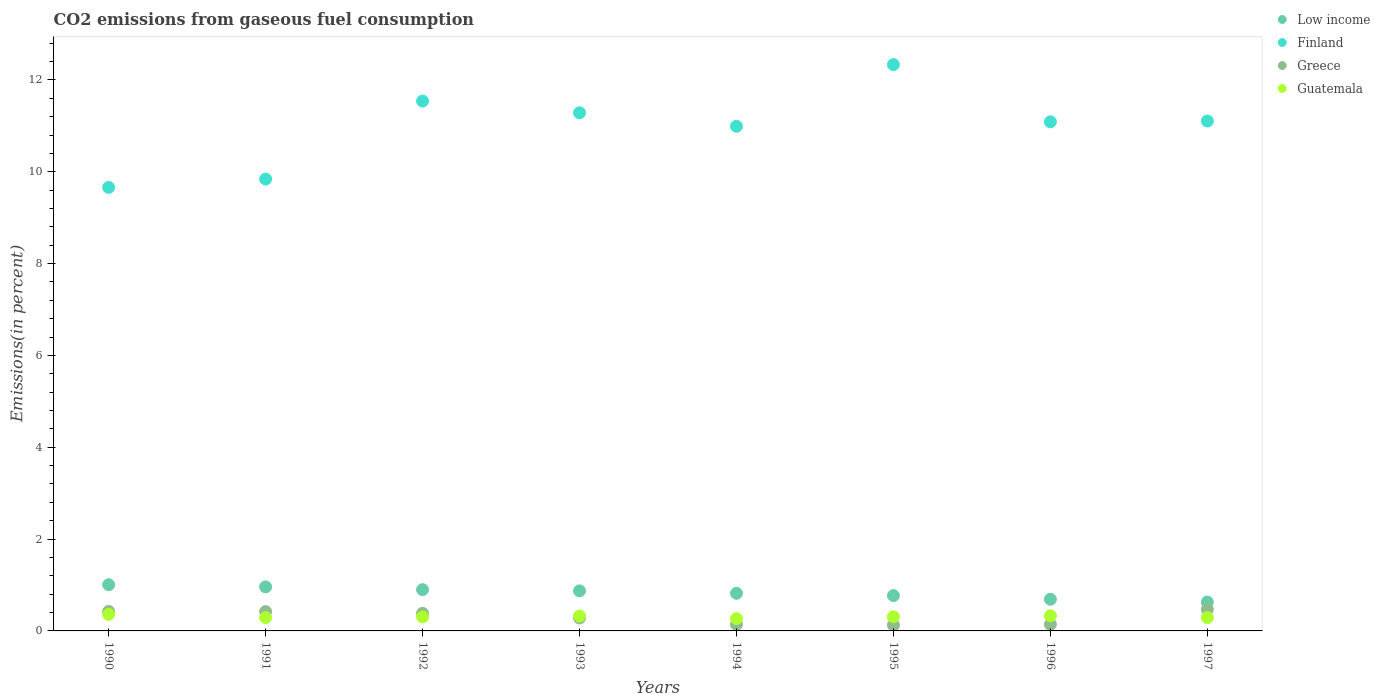How many different coloured dotlines are there?
Keep it short and to the point. 4. What is the total CO2 emitted in Low income in 1996?
Keep it short and to the point. 0.69. Across all years, what is the maximum total CO2 emitted in Guatemala?
Provide a short and direct response. 0.36. Across all years, what is the minimum total CO2 emitted in Greece?
Offer a terse response. 0.13. In which year was the total CO2 emitted in Low income maximum?
Your answer should be very brief. 1990. In which year was the total CO2 emitted in Guatemala minimum?
Your answer should be very brief. 1994. What is the total total CO2 emitted in Guatemala in the graph?
Provide a succinct answer. 2.47. What is the difference between the total CO2 emitted in Finland in 1990 and that in 1995?
Offer a terse response. -2.67. What is the difference between the total CO2 emitted in Finland in 1997 and the total CO2 emitted in Greece in 1995?
Give a very brief answer. 10.98. What is the average total CO2 emitted in Finland per year?
Make the answer very short. 10.98. In the year 1997, what is the difference between the total CO2 emitted in Greece and total CO2 emitted in Finland?
Ensure brevity in your answer.  -10.64. What is the ratio of the total CO2 emitted in Greece in 1993 to that in 1997?
Your answer should be compact. 0.6. Is the total CO2 emitted in Greece in 1990 less than that in 1993?
Provide a succinct answer. No. What is the difference between the highest and the second highest total CO2 emitted in Low income?
Keep it short and to the point. 0.05. What is the difference between the highest and the lowest total CO2 emitted in Guatemala?
Your response must be concise. 0.09. Is the sum of the total CO2 emitted in Finland in 1994 and 1996 greater than the maximum total CO2 emitted in Greece across all years?
Provide a succinct answer. Yes. Is it the case that in every year, the sum of the total CO2 emitted in Greece and total CO2 emitted in Guatemala  is greater than the sum of total CO2 emitted in Low income and total CO2 emitted in Finland?
Your answer should be compact. No. Is it the case that in every year, the sum of the total CO2 emitted in Guatemala and total CO2 emitted in Greece  is greater than the total CO2 emitted in Low income?
Ensure brevity in your answer.  No. How many dotlines are there?
Ensure brevity in your answer.  4. How many years are there in the graph?
Offer a very short reply. 8. What is the difference between two consecutive major ticks on the Y-axis?
Give a very brief answer. 2. Does the graph contain grids?
Your answer should be compact. No. How many legend labels are there?
Keep it short and to the point. 4. What is the title of the graph?
Your response must be concise. CO2 emissions from gaseous fuel consumption. What is the label or title of the Y-axis?
Give a very brief answer. Emissions(in percent). What is the Emissions(in percent) in Low income in 1990?
Offer a very short reply. 1.01. What is the Emissions(in percent) in Finland in 1990?
Your answer should be very brief. 9.66. What is the Emissions(in percent) of Greece in 1990?
Give a very brief answer. 0.42. What is the Emissions(in percent) of Guatemala in 1990?
Your response must be concise. 0.36. What is the Emissions(in percent) of Low income in 1991?
Offer a terse response. 0.96. What is the Emissions(in percent) of Finland in 1991?
Your answer should be very brief. 9.84. What is the Emissions(in percent) in Greece in 1991?
Your answer should be very brief. 0.42. What is the Emissions(in percent) in Guatemala in 1991?
Provide a short and direct response. 0.29. What is the Emissions(in percent) of Low income in 1992?
Offer a terse response. 0.9. What is the Emissions(in percent) of Finland in 1992?
Make the answer very short. 11.54. What is the Emissions(in percent) in Greece in 1992?
Your response must be concise. 0.38. What is the Emissions(in percent) in Guatemala in 1992?
Give a very brief answer. 0.3. What is the Emissions(in percent) of Low income in 1993?
Provide a succinct answer. 0.87. What is the Emissions(in percent) of Finland in 1993?
Offer a very short reply. 11.28. What is the Emissions(in percent) in Greece in 1993?
Your answer should be very brief. 0.28. What is the Emissions(in percent) in Guatemala in 1993?
Ensure brevity in your answer.  0.32. What is the Emissions(in percent) in Low income in 1994?
Keep it short and to the point. 0.82. What is the Emissions(in percent) of Finland in 1994?
Offer a very short reply. 10.99. What is the Emissions(in percent) of Greece in 1994?
Make the answer very short. 0.14. What is the Emissions(in percent) in Guatemala in 1994?
Keep it short and to the point. 0.27. What is the Emissions(in percent) of Low income in 1995?
Your answer should be very brief. 0.77. What is the Emissions(in percent) in Finland in 1995?
Make the answer very short. 12.33. What is the Emissions(in percent) of Greece in 1995?
Give a very brief answer. 0.13. What is the Emissions(in percent) of Guatemala in 1995?
Give a very brief answer. 0.31. What is the Emissions(in percent) of Low income in 1996?
Your answer should be very brief. 0.69. What is the Emissions(in percent) of Finland in 1996?
Provide a short and direct response. 11.09. What is the Emissions(in percent) of Greece in 1996?
Offer a very short reply. 0.14. What is the Emissions(in percent) of Guatemala in 1996?
Keep it short and to the point. 0.33. What is the Emissions(in percent) in Low income in 1997?
Provide a short and direct response. 0.63. What is the Emissions(in percent) of Finland in 1997?
Your response must be concise. 11.1. What is the Emissions(in percent) in Greece in 1997?
Ensure brevity in your answer.  0.47. What is the Emissions(in percent) of Guatemala in 1997?
Ensure brevity in your answer.  0.29. Across all years, what is the maximum Emissions(in percent) of Low income?
Make the answer very short. 1.01. Across all years, what is the maximum Emissions(in percent) of Finland?
Ensure brevity in your answer.  12.33. Across all years, what is the maximum Emissions(in percent) in Greece?
Give a very brief answer. 0.47. Across all years, what is the maximum Emissions(in percent) of Guatemala?
Your response must be concise. 0.36. Across all years, what is the minimum Emissions(in percent) in Low income?
Your response must be concise. 0.63. Across all years, what is the minimum Emissions(in percent) of Finland?
Provide a succinct answer. 9.66. Across all years, what is the minimum Emissions(in percent) in Greece?
Give a very brief answer. 0.13. Across all years, what is the minimum Emissions(in percent) in Guatemala?
Your response must be concise. 0.27. What is the total Emissions(in percent) in Low income in the graph?
Ensure brevity in your answer.  6.64. What is the total Emissions(in percent) in Finland in the graph?
Give a very brief answer. 87.84. What is the total Emissions(in percent) of Greece in the graph?
Offer a very short reply. 2.39. What is the total Emissions(in percent) of Guatemala in the graph?
Make the answer very short. 2.48. What is the difference between the Emissions(in percent) in Low income in 1990 and that in 1991?
Make the answer very short. 0.05. What is the difference between the Emissions(in percent) in Finland in 1990 and that in 1991?
Ensure brevity in your answer.  -0.18. What is the difference between the Emissions(in percent) of Greece in 1990 and that in 1991?
Provide a succinct answer. 0. What is the difference between the Emissions(in percent) of Guatemala in 1990 and that in 1991?
Your response must be concise. 0.07. What is the difference between the Emissions(in percent) of Low income in 1990 and that in 1992?
Your answer should be very brief. 0.11. What is the difference between the Emissions(in percent) of Finland in 1990 and that in 1992?
Provide a succinct answer. -1.88. What is the difference between the Emissions(in percent) in Greece in 1990 and that in 1992?
Provide a succinct answer. 0.04. What is the difference between the Emissions(in percent) in Guatemala in 1990 and that in 1992?
Offer a terse response. 0.06. What is the difference between the Emissions(in percent) in Low income in 1990 and that in 1993?
Your response must be concise. 0.13. What is the difference between the Emissions(in percent) in Finland in 1990 and that in 1993?
Keep it short and to the point. -1.62. What is the difference between the Emissions(in percent) in Greece in 1990 and that in 1993?
Give a very brief answer. 0.14. What is the difference between the Emissions(in percent) of Guatemala in 1990 and that in 1993?
Provide a succinct answer. 0.04. What is the difference between the Emissions(in percent) of Low income in 1990 and that in 1994?
Offer a terse response. 0.19. What is the difference between the Emissions(in percent) of Finland in 1990 and that in 1994?
Provide a short and direct response. -1.33. What is the difference between the Emissions(in percent) of Greece in 1990 and that in 1994?
Ensure brevity in your answer.  0.28. What is the difference between the Emissions(in percent) of Guatemala in 1990 and that in 1994?
Your answer should be very brief. 0.09. What is the difference between the Emissions(in percent) of Low income in 1990 and that in 1995?
Your answer should be compact. 0.24. What is the difference between the Emissions(in percent) of Finland in 1990 and that in 1995?
Provide a short and direct response. -2.67. What is the difference between the Emissions(in percent) of Greece in 1990 and that in 1995?
Offer a very short reply. 0.3. What is the difference between the Emissions(in percent) in Guatemala in 1990 and that in 1995?
Ensure brevity in your answer.  0.05. What is the difference between the Emissions(in percent) in Low income in 1990 and that in 1996?
Your answer should be compact. 0.32. What is the difference between the Emissions(in percent) of Finland in 1990 and that in 1996?
Provide a succinct answer. -1.43. What is the difference between the Emissions(in percent) in Greece in 1990 and that in 1996?
Offer a terse response. 0.28. What is the difference between the Emissions(in percent) of Guatemala in 1990 and that in 1996?
Offer a very short reply. 0.03. What is the difference between the Emissions(in percent) of Low income in 1990 and that in 1997?
Provide a succinct answer. 0.38. What is the difference between the Emissions(in percent) of Finland in 1990 and that in 1997?
Make the answer very short. -1.45. What is the difference between the Emissions(in percent) in Greece in 1990 and that in 1997?
Provide a succinct answer. -0.04. What is the difference between the Emissions(in percent) in Guatemala in 1990 and that in 1997?
Your answer should be very brief. 0.07. What is the difference between the Emissions(in percent) in Low income in 1991 and that in 1992?
Your response must be concise. 0.06. What is the difference between the Emissions(in percent) in Finland in 1991 and that in 1992?
Provide a short and direct response. -1.7. What is the difference between the Emissions(in percent) in Greece in 1991 and that in 1992?
Offer a terse response. 0.04. What is the difference between the Emissions(in percent) of Guatemala in 1991 and that in 1992?
Your answer should be very brief. -0.01. What is the difference between the Emissions(in percent) of Low income in 1991 and that in 1993?
Your answer should be very brief. 0.09. What is the difference between the Emissions(in percent) in Finland in 1991 and that in 1993?
Ensure brevity in your answer.  -1.44. What is the difference between the Emissions(in percent) of Greece in 1991 and that in 1993?
Ensure brevity in your answer.  0.14. What is the difference between the Emissions(in percent) in Guatemala in 1991 and that in 1993?
Your response must be concise. -0.03. What is the difference between the Emissions(in percent) in Low income in 1991 and that in 1994?
Give a very brief answer. 0.14. What is the difference between the Emissions(in percent) in Finland in 1991 and that in 1994?
Offer a terse response. -1.15. What is the difference between the Emissions(in percent) of Greece in 1991 and that in 1994?
Provide a succinct answer. 0.28. What is the difference between the Emissions(in percent) in Guatemala in 1991 and that in 1994?
Keep it short and to the point. 0.02. What is the difference between the Emissions(in percent) of Low income in 1991 and that in 1995?
Offer a terse response. 0.19. What is the difference between the Emissions(in percent) of Finland in 1991 and that in 1995?
Offer a terse response. -2.49. What is the difference between the Emissions(in percent) of Greece in 1991 and that in 1995?
Make the answer very short. 0.3. What is the difference between the Emissions(in percent) in Guatemala in 1991 and that in 1995?
Ensure brevity in your answer.  -0.02. What is the difference between the Emissions(in percent) in Low income in 1991 and that in 1996?
Your response must be concise. 0.27. What is the difference between the Emissions(in percent) in Finland in 1991 and that in 1996?
Make the answer very short. -1.25. What is the difference between the Emissions(in percent) of Greece in 1991 and that in 1996?
Provide a succinct answer. 0.28. What is the difference between the Emissions(in percent) in Guatemala in 1991 and that in 1996?
Keep it short and to the point. -0.04. What is the difference between the Emissions(in percent) in Low income in 1991 and that in 1997?
Your answer should be very brief. 0.33. What is the difference between the Emissions(in percent) of Finland in 1991 and that in 1997?
Give a very brief answer. -1.26. What is the difference between the Emissions(in percent) of Greece in 1991 and that in 1997?
Provide a succinct answer. -0.05. What is the difference between the Emissions(in percent) of Guatemala in 1991 and that in 1997?
Your answer should be very brief. 0. What is the difference between the Emissions(in percent) in Low income in 1992 and that in 1993?
Ensure brevity in your answer.  0.03. What is the difference between the Emissions(in percent) of Finland in 1992 and that in 1993?
Make the answer very short. 0.26. What is the difference between the Emissions(in percent) of Greece in 1992 and that in 1993?
Provide a short and direct response. 0.1. What is the difference between the Emissions(in percent) of Guatemala in 1992 and that in 1993?
Your answer should be very brief. -0.02. What is the difference between the Emissions(in percent) of Low income in 1992 and that in 1994?
Your answer should be very brief. 0.08. What is the difference between the Emissions(in percent) of Finland in 1992 and that in 1994?
Ensure brevity in your answer.  0.55. What is the difference between the Emissions(in percent) in Greece in 1992 and that in 1994?
Provide a short and direct response. 0.24. What is the difference between the Emissions(in percent) in Guatemala in 1992 and that in 1994?
Offer a terse response. 0.04. What is the difference between the Emissions(in percent) of Low income in 1992 and that in 1995?
Ensure brevity in your answer.  0.13. What is the difference between the Emissions(in percent) of Finland in 1992 and that in 1995?
Ensure brevity in your answer.  -0.79. What is the difference between the Emissions(in percent) in Greece in 1992 and that in 1995?
Offer a very short reply. 0.26. What is the difference between the Emissions(in percent) of Guatemala in 1992 and that in 1995?
Your answer should be very brief. -0. What is the difference between the Emissions(in percent) of Low income in 1992 and that in 1996?
Your answer should be very brief. 0.21. What is the difference between the Emissions(in percent) of Finland in 1992 and that in 1996?
Give a very brief answer. 0.45. What is the difference between the Emissions(in percent) in Greece in 1992 and that in 1996?
Make the answer very short. 0.24. What is the difference between the Emissions(in percent) of Guatemala in 1992 and that in 1996?
Provide a short and direct response. -0.03. What is the difference between the Emissions(in percent) in Low income in 1992 and that in 1997?
Give a very brief answer. 0.27. What is the difference between the Emissions(in percent) in Finland in 1992 and that in 1997?
Keep it short and to the point. 0.44. What is the difference between the Emissions(in percent) of Greece in 1992 and that in 1997?
Your answer should be compact. -0.09. What is the difference between the Emissions(in percent) of Guatemala in 1992 and that in 1997?
Offer a terse response. 0.02. What is the difference between the Emissions(in percent) of Low income in 1993 and that in 1994?
Your answer should be compact. 0.05. What is the difference between the Emissions(in percent) in Finland in 1993 and that in 1994?
Provide a short and direct response. 0.29. What is the difference between the Emissions(in percent) of Greece in 1993 and that in 1994?
Your answer should be very brief. 0.14. What is the difference between the Emissions(in percent) of Guatemala in 1993 and that in 1994?
Offer a terse response. 0.06. What is the difference between the Emissions(in percent) of Low income in 1993 and that in 1995?
Provide a short and direct response. 0.1. What is the difference between the Emissions(in percent) in Finland in 1993 and that in 1995?
Keep it short and to the point. -1.05. What is the difference between the Emissions(in percent) in Greece in 1993 and that in 1995?
Your response must be concise. 0.16. What is the difference between the Emissions(in percent) of Guatemala in 1993 and that in 1995?
Your answer should be very brief. 0.02. What is the difference between the Emissions(in percent) of Low income in 1993 and that in 1996?
Provide a short and direct response. 0.18. What is the difference between the Emissions(in percent) in Finland in 1993 and that in 1996?
Your answer should be very brief. 0.2. What is the difference between the Emissions(in percent) of Greece in 1993 and that in 1996?
Ensure brevity in your answer.  0.14. What is the difference between the Emissions(in percent) of Guatemala in 1993 and that in 1996?
Offer a terse response. -0.01. What is the difference between the Emissions(in percent) in Low income in 1993 and that in 1997?
Your answer should be compact. 0.24. What is the difference between the Emissions(in percent) of Finland in 1993 and that in 1997?
Offer a very short reply. 0.18. What is the difference between the Emissions(in percent) of Greece in 1993 and that in 1997?
Offer a terse response. -0.19. What is the difference between the Emissions(in percent) of Guatemala in 1993 and that in 1997?
Your response must be concise. 0.03. What is the difference between the Emissions(in percent) of Low income in 1994 and that in 1995?
Your response must be concise. 0.05. What is the difference between the Emissions(in percent) of Finland in 1994 and that in 1995?
Keep it short and to the point. -1.34. What is the difference between the Emissions(in percent) of Greece in 1994 and that in 1995?
Ensure brevity in your answer.  0.02. What is the difference between the Emissions(in percent) in Guatemala in 1994 and that in 1995?
Keep it short and to the point. -0.04. What is the difference between the Emissions(in percent) of Low income in 1994 and that in 1996?
Offer a very short reply. 0.13. What is the difference between the Emissions(in percent) of Finland in 1994 and that in 1996?
Your response must be concise. -0.1. What is the difference between the Emissions(in percent) of Greece in 1994 and that in 1996?
Make the answer very short. -0. What is the difference between the Emissions(in percent) in Guatemala in 1994 and that in 1996?
Your answer should be compact. -0.06. What is the difference between the Emissions(in percent) in Low income in 1994 and that in 1997?
Your response must be concise. 0.19. What is the difference between the Emissions(in percent) in Finland in 1994 and that in 1997?
Your response must be concise. -0.11. What is the difference between the Emissions(in percent) in Greece in 1994 and that in 1997?
Your answer should be compact. -0.33. What is the difference between the Emissions(in percent) of Guatemala in 1994 and that in 1997?
Make the answer very short. -0.02. What is the difference between the Emissions(in percent) of Low income in 1995 and that in 1996?
Your response must be concise. 0.08. What is the difference between the Emissions(in percent) in Finland in 1995 and that in 1996?
Offer a very short reply. 1.25. What is the difference between the Emissions(in percent) in Greece in 1995 and that in 1996?
Your answer should be compact. -0.02. What is the difference between the Emissions(in percent) in Guatemala in 1995 and that in 1996?
Provide a short and direct response. -0.02. What is the difference between the Emissions(in percent) of Low income in 1995 and that in 1997?
Offer a terse response. 0.14. What is the difference between the Emissions(in percent) of Finland in 1995 and that in 1997?
Your answer should be compact. 1.23. What is the difference between the Emissions(in percent) in Greece in 1995 and that in 1997?
Your response must be concise. -0.34. What is the difference between the Emissions(in percent) in Guatemala in 1995 and that in 1997?
Your answer should be compact. 0.02. What is the difference between the Emissions(in percent) of Low income in 1996 and that in 1997?
Keep it short and to the point. 0.06. What is the difference between the Emissions(in percent) in Finland in 1996 and that in 1997?
Provide a short and direct response. -0.02. What is the difference between the Emissions(in percent) of Greece in 1996 and that in 1997?
Your answer should be compact. -0.33. What is the difference between the Emissions(in percent) in Guatemala in 1996 and that in 1997?
Give a very brief answer. 0.04. What is the difference between the Emissions(in percent) of Low income in 1990 and the Emissions(in percent) of Finland in 1991?
Provide a succinct answer. -8.83. What is the difference between the Emissions(in percent) of Low income in 1990 and the Emissions(in percent) of Greece in 1991?
Make the answer very short. 0.58. What is the difference between the Emissions(in percent) in Low income in 1990 and the Emissions(in percent) in Guatemala in 1991?
Your answer should be compact. 0.72. What is the difference between the Emissions(in percent) of Finland in 1990 and the Emissions(in percent) of Greece in 1991?
Give a very brief answer. 9.24. What is the difference between the Emissions(in percent) of Finland in 1990 and the Emissions(in percent) of Guatemala in 1991?
Offer a terse response. 9.37. What is the difference between the Emissions(in percent) of Greece in 1990 and the Emissions(in percent) of Guatemala in 1991?
Give a very brief answer. 0.13. What is the difference between the Emissions(in percent) of Low income in 1990 and the Emissions(in percent) of Finland in 1992?
Your response must be concise. -10.53. What is the difference between the Emissions(in percent) in Low income in 1990 and the Emissions(in percent) in Greece in 1992?
Make the answer very short. 0.62. What is the difference between the Emissions(in percent) in Low income in 1990 and the Emissions(in percent) in Guatemala in 1992?
Offer a terse response. 0.7. What is the difference between the Emissions(in percent) in Finland in 1990 and the Emissions(in percent) in Greece in 1992?
Your answer should be very brief. 9.28. What is the difference between the Emissions(in percent) in Finland in 1990 and the Emissions(in percent) in Guatemala in 1992?
Your answer should be compact. 9.35. What is the difference between the Emissions(in percent) in Greece in 1990 and the Emissions(in percent) in Guatemala in 1992?
Provide a short and direct response. 0.12. What is the difference between the Emissions(in percent) in Low income in 1990 and the Emissions(in percent) in Finland in 1993?
Ensure brevity in your answer.  -10.28. What is the difference between the Emissions(in percent) in Low income in 1990 and the Emissions(in percent) in Greece in 1993?
Provide a succinct answer. 0.72. What is the difference between the Emissions(in percent) of Low income in 1990 and the Emissions(in percent) of Guatemala in 1993?
Offer a terse response. 0.68. What is the difference between the Emissions(in percent) of Finland in 1990 and the Emissions(in percent) of Greece in 1993?
Give a very brief answer. 9.38. What is the difference between the Emissions(in percent) of Finland in 1990 and the Emissions(in percent) of Guatemala in 1993?
Your response must be concise. 9.34. What is the difference between the Emissions(in percent) in Greece in 1990 and the Emissions(in percent) in Guatemala in 1993?
Give a very brief answer. 0.1. What is the difference between the Emissions(in percent) of Low income in 1990 and the Emissions(in percent) of Finland in 1994?
Offer a very short reply. -9.98. What is the difference between the Emissions(in percent) in Low income in 1990 and the Emissions(in percent) in Greece in 1994?
Provide a short and direct response. 0.86. What is the difference between the Emissions(in percent) in Low income in 1990 and the Emissions(in percent) in Guatemala in 1994?
Make the answer very short. 0.74. What is the difference between the Emissions(in percent) in Finland in 1990 and the Emissions(in percent) in Greece in 1994?
Your answer should be compact. 9.52. What is the difference between the Emissions(in percent) of Finland in 1990 and the Emissions(in percent) of Guatemala in 1994?
Ensure brevity in your answer.  9.39. What is the difference between the Emissions(in percent) of Greece in 1990 and the Emissions(in percent) of Guatemala in 1994?
Your response must be concise. 0.16. What is the difference between the Emissions(in percent) in Low income in 1990 and the Emissions(in percent) in Finland in 1995?
Your answer should be compact. -11.33. What is the difference between the Emissions(in percent) in Low income in 1990 and the Emissions(in percent) in Greece in 1995?
Ensure brevity in your answer.  0.88. What is the difference between the Emissions(in percent) of Low income in 1990 and the Emissions(in percent) of Guatemala in 1995?
Ensure brevity in your answer.  0.7. What is the difference between the Emissions(in percent) of Finland in 1990 and the Emissions(in percent) of Greece in 1995?
Provide a succinct answer. 9.53. What is the difference between the Emissions(in percent) of Finland in 1990 and the Emissions(in percent) of Guatemala in 1995?
Give a very brief answer. 9.35. What is the difference between the Emissions(in percent) in Greece in 1990 and the Emissions(in percent) in Guatemala in 1995?
Give a very brief answer. 0.12. What is the difference between the Emissions(in percent) of Low income in 1990 and the Emissions(in percent) of Finland in 1996?
Ensure brevity in your answer.  -10.08. What is the difference between the Emissions(in percent) of Low income in 1990 and the Emissions(in percent) of Greece in 1996?
Offer a very short reply. 0.86. What is the difference between the Emissions(in percent) in Low income in 1990 and the Emissions(in percent) in Guatemala in 1996?
Your answer should be very brief. 0.68. What is the difference between the Emissions(in percent) in Finland in 1990 and the Emissions(in percent) in Greece in 1996?
Offer a terse response. 9.52. What is the difference between the Emissions(in percent) in Finland in 1990 and the Emissions(in percent) in Guatemala in 1996?
Offer a terse response. 9.33. What is the difference between the Emissions(in percent) in Greece in 1990 and the Emissions(in percent) in Guatemala in 1996?
Provide a succinct answer. 0.09. What is the difference between the Emissions(in percent) in Low income in 1990 and the Emissions(in percent) in Finland in 1997?
Offer a very short reply. -10.1. What is the difference between the Emissions(in percent) in Low income in 1990 and the Emissions(in percent) in Greece in 1997?
Give a very brief answer. 0.54. What is the difference between the Emissions(in percent) of Low income in 1990 and the Emissions(in percent) of Guatemala in 1997?
Ensure brevity in your answer.  0.72. What is the difference between the Emissions(in percent) in Finland in 1990 and the Emissions(in percent) in Greece in 1997?
Make the answer very short. 9.19. What is the difference between the Emissions(in percent) of Finland in 1990 and the Emissions(in percent) of Guatemala in 1997?
Offer a terse response. 9.37. What is the difference between the Emissions(in percent) of Greece in 1990 and the Emissions(in percent) of Guatemala in 1997?
Give a very brief answer. 0.14. What is the difference between the Emissions(in percent) in Low income in 1991 and the Emissions(in percent) in Finland in 1992?
Your answer should be compact. -10.58. What is the difference between the Emissions(in percent) of Low income in 1991 and the Emissions(in percent) of Greece in 1992?
Make the answer very short. 0.58. What is the difference between the Emissions(in percent) of Low income in 1991 and the Emissions(in percent) of Guatemala in 1992?
Give a very brief answer. 0.65. What is the difference between the Emissions(in percent) of Finland in 1991 and the Emissions(in percent) of Greece in 1992?
Give a very brief answer. 9.46. What is the difference between the Emissions(in percent) of Finland in 1991 and the Emissions(in percent) of Guatemala in 1992?
Your answer should be very brief. 9.54. What is the difference between the Emissions(in percent) in Greece in 1991 and the Emissions(in percent) in Guatemala in 1992?
Your answer should be very brief. 0.12. What is the difference between the Emissions(in percent) of Low income in 1991 and the Emissions(in percent) of Finland in 1993?
Keep it short and to the point. -10.32. What is the difference between the Emissions(in percent) in Low income in 1991 and the Emissions(in percent) in Greece in 1993?
Provide a short and direct response. 0.68. What is the difference between the Emissions(in percent) of Low income in 1991 and the Emissions(in percent) of Guatemala in 1993?
Keep it short and to the point. 0.64. What is the difference between the Emissions(in percent) in Finland in 1991 and the Emissions(in percent) in Greece in 1993?
Your response must be concise. 9.56. What is the difference between the Emissions(in percent) of Finland in 1991 and the Emissions(in percent) of Guatemala in 1993?
Offer a terse response. 9.52. What is the difference between the Emissions(in percent) of Greece in 1991 and the Emissions(in percent) of Guatemala in 1993?
Provide a succinct answer. 0.1. What is the difference between the Emissions(in percent) in Low income in 1991 and the Emissions(in percent) in Finland in 1994?
Provide a succinct answer. -10.03. What is the difference between the Emissions(in percent) in Low income in 1991 and the Emissions(in percent) in Greece in 1994?
Provide a short and direct response. 0.82. What is the difference between the Emissions(in percent) in Low income in 1991 and the Emissions(in percent) in Guatemala in 1994?
Offer a terse response. 0.69. What is the difference between the Emissions(in percent) in Finland in 1991 and the Emissions(in percent) in Greece in 1994?
Your answer should be compact. 9.7. What is the difference between the Emissions(in percent) of Finland in 1991 and the Emissions(in percent) of Guatemala in 1994?
Your answer should be very brief. 9.57. What is the difference between the Emissions(in percent) in Greece in 1991 and the Emissions(in percent) in Guatemala in 1994?
Make the answer very short. 0.15. What is the difference between the Emissions(in percent) in Low income in 1991 and the Emissions(in percent) in Finland in 1995?
Keep it short and to the point. -11.37. What is the difference between the Emissions(in percent) of Low income in 1991 and the Emissions(in percent) of Greece in 1995?
Your response must be concise. 0.83. What is the difference between the Emissions(in percent) in Low income in 1991 and the Emissions(in percent) in Guatemala in 1995?
Give a very brief answer. 0.65. What is the difference between the Emissions(in percent) in Finland in 1991 and the Emissions(in percent) in Greece in 1995?
Keep it short and to the point. 9.71. What is the difference between the Emissions(in percent) of Finland in 1991 and the Emissions(in percent) of Guatemala in 1995?
Your answer should be very brief. 9.53. What is the difference between the Emissions(in percent) in Greece in 1991 and the Emissions(in percent) in Guatemala in 1995?
Your answer should be very brief. 0.11. What is the difference between the Emissions(in percent) in Low income in 1991 and the Emissions(in percent) in Finland in 1996?
Your response must be concise. -10.13. What is the difference between the Emissions(in percent) of Low income in 1991 and the Emissions(in percent) of Greece in 1996?
Provide a succinct answer. 0.82. What is the difference between the Emissions(in percent) of Low income in 1991 and the Emissions(in percent) of Guatemala in 1996?
Keep it short and to the point. 0.63. What is the difference between the Emissions(in percent) in Finland in 1991 and the Emissions(in percent) in Greece in 1996?
Provide a succinct answer. 9.7. What is the difference between the Emissions(in percent) in Finland in 1991 and the Emissions(in percent) in Guatemala in 1996?
Give a very brief answer. 9.51. What is the difference between the Emissions(in percent) in Greece in 1991 and the Emissions(in percent) in Guatemala in 1996?
Offer a very short reply. 0.09. What is the difference between the Emissions(in percent) in Low income in 1991 and the Emissions(in percent) in Finland in 1997?
Provide a succinct answer. -10.15. What is the difference between the Emissions(in percent) in Low income in 1991 and the Emissions(in percent) in Greece in 1997?
Keep it short and to the point. 0.49. What is the difference between the Emissions(in percent) of Low income in 1991 and the Emissions(in percent) of Guatemala in 1997?
Your answer should be very brief. 0.67. What is the difference between the Emissions(in percent) in Finland in 1991 and the Emissions(in percent) in Greece in 1997?
Your answer should be very brief. 9.37. What is the difference between the Emissions(in percent) of Finland in 1991 and the Emissions(in percent) of Guatemala in 1997?
Keep it short and to the point. 9.55. What is the difference between the Emissions(in percent) of Greece in 1991 and the Emissions(in percent) of Guatemala in 1997?
Offer a very short reply. 0.13. What is the difference between the Emissions(in percent) in Low income in 1992 and the Emissions(in percent) in Finland in 1993?
Your answer should be compact. -10.39. What is the difference between the Emissions(in percent) of Low income in 1992 and the Emissions(in percent) of Greece in 1993?
Provide a succinct answer. 0.62. What is the difference between the Emissions(in percent) of Low income in 1992 and the Emissions(in percent) of Guatemala in 1993?
Your answer should be compact. 0.57. What is the difference between the Emissions(in percent) of Finland in 1992 and the Emissions(in percent) of Greece in 1993?
Your answer should be very brief. 11.26. What is the difference between the Emissions(in percent) in Finland in 1992 and the Emissions(in percent) in Guatemala in 1993?
Your answer should be compact. 11.22. What is the difference between the Emissions(in percent) in Greece in 1992 and the Emissions(in percent) in Guatemala in 1993?
Give a very brief answer. 0.06. What is the difference between the Emissions(in percent) in Low income in 1992 and the Emissions(in percent) in Finland in 1994?
Offer a very short reply. -10.09. What is the difference between the Emissions(in percent) of Low income in 1992 and the Emissions(in percent) of Greece in 1994?
Offer a terse response. 0.76. What is the difference between the Emissions(in percent) of Low income in 1992 and the Emissions(in percent) of Guatemala in 1994?
Ensure brevity in your answer.  0.63. What is the difference between the Emissions(in percent) of Finland in 1992 and the Emissions(in percent) of Greece in 1994?
Your answer should be compact. 11.4. What is the difference between the Emissions(in percent) of Finland in 1992 and the Emissions(in percent) of Guatemala in 1994?
Make the answer very short. 11.27. What is the difference between the Emissions(in percent) in Greece in 1992 and the Emissions(in percent) in Guatemala in 1994?
Provide a short and direct response. 0.12. What is the difference between the Emissions(in percent) of Low income in 1992 and the Emissions(in percent) of Finland in 1995?
Offer a terse response. -11.44. What is the difference between the Emissions(in percent) in Low income in 1992 and the Emissions(in percent) in Greece in 1995?
Your answer should be very brief. 0.77. What is the difference between the Emissions(in percent) of Low income in 1992 and the Emissions(in percent) of Guatemala in 1995?
Your answer should be compact. 0.59. What is the difference between the Emissions(in percent) in Finland in 1992 and the Emissions(in percent) in Greece in 1995?
Offer a very short reply. 11.41. What is the difference between the Emissions(in percent) of Finland in 1992 and the Emissions(in percent) of Guatemala in 1995?
Offer a very short reply. 11.23. What is the difference between the Emissions(in percent) in Greece in 1992 and the Emissions(in percent) in Guatemala in 1995?
Your response must be concise. 0.08. What is the difference between the Emissions(in percent) of Low income in 1992 and the Emissions(in percent) of Finland in 1996?
Ensure brevity in your answer.  -10.19. What is the difference between the Emissions(in percent) of Low income in 1992 and the Emissions(in percent) of Greece in 1996?
Keep it short and to the point. 0.76. What is the difference between the Emissions(in percent) of Low income in 1992 and the Emissions(in percent) of Guatemala in 1996?
Your answer should be compact. 0.57. What is the difference between the Emissions(in percent) of Finland in 1992 and the Emissions(in percent) of Greece in 1996?
Your response must be concise. 11.4. What is the difference between the Emissions(in percent) of Finland in 1992 and the Emissions(in percent) of Guatemala in 1996?
Offer a very short reply. 11.21. What is the difference between the Emissions(in percent) in Greece in 1992 and the Emissions(in percent) in Guatemala in 1996?
Your answer should be very brief. 0.05. What is the difference between the Emissions(in percent) in Low income in 1992 and the Emissions(in percent) in Finland in 1997?
Provide a short and direct response. -10.21. What is the difference between the Emissions(in percent) of Low income in 1992 and the Emissions(in percent) of Greece in 1997?
Offer a terse response. 0.43. What is the difference between the Emissions(in percent) of Low income in 1992 and the Emissions(in percent) of Guatemala in 1997?
Your answer should be very brief. 0.61. What is the difference between the Emissions(in percent) in Finland in 1992 and the Emissions(in percent) in Greece in 1997?
Ensure brevity in your answer.  11.07. What is the difference between the Emissions(in percent) of Finland in 1992 and the Emissions(in percent) of Guatemala in 1997?
Your answer should be very brief. 11.25. What is the difference between the Emissions(in percent) in Greece in 1992 and the Emissions(in percent) in Guatemala in 1997?
Provide a succinct answer. 0.09. What is the difference between the Emissions(in percent) in Low income in 1993 and the Emissions(in percent) in Finland in 1994?
Make the answer very short. -10.12. What is the difference between the Emissions(in percent) of Low income in 1993 and the Emissions(in percent) of Greece in 1994?
Keep it short and to the point. 0.73. What is the difference between the Emissions(in percent) of Low income in 1993 and the Emissions(in percent) of Guatemala in 1994?
Your answer should be very brief. 0.6. What is the difference between the Emissions(in percent) of Finland in 1993 and the Emissions(in percent) of Greece in 1994?
Make the answer very short. 11.14. What is the difference between the Emissions(in percent) of Finland in 1993 and the Emissions(in percent) of Guatemala in 1994?
Provide a succinct answer. 11.02. What is the difference between the Emissions(in percent) of Greece in 1993 and the Emissions(in percent) of Guatemala in 1994?
Offer a terse response. 0.01. What is the difference between the Emissions(in percent) of Low income in 1993 and the Emissions(in percent) of Finland in 1995?
Provide a short and direct response. -11.46. What is the difference between the Emissions(in percent) of Low income in 1993 and the Emissions(in percent) of Greece in 1995?
Your answer should be compact. 0.75. What is the difference between the Emissions(in percent) in Low income in 1993 and the Emissions(in percent) in Guatemala in 1995?
Make the answer very short. 0.57. What is the difference between the Emissions(in percent) in Finland in 1993 and the Emissions(in percent) in Greece in 1995?
Your response must be concise. 11.16. What is the difference between the Emissions(in percent) in Finland in 1993 and the Emissions(in percent) in Guatemala in 1995?
Ensure brevity in your answer.  10.98. What is the difference between the Emissions(in percent) in Greece in 1993 and the Emissions(in percent) in Guatemala in 1995?
Ensure brevity in your answer.  -0.03. What is the difference between the Emissions(in percent) in Low income in 1993 and the Emissions(in percent) in Finland in 1996?
Give a very brief answer. -10.22. What is the difference between the Emissions(in percent) of Low income in 1993 and the Emissions(in percent) of Greece in 1996?
Your answer should be very brief. 0.73. What is the difference between the Emissions(in percent) in Low income in 1993 and the Emissions(in percent) in Guatemala in 1996?
Your answer should be very brief. 0.54. What is the difference between the Emissions(in percent) of Finland in 1993 and the Emissions(in percent) of Greece in 1996?
Make the answer very short. 11.14. What is the difference between the Emissions(in percent) in Finland in 1993 and the Emissions(in percent) in Guatemala in 1996?
Offer a very short reply. 10.95. What is the difference between the Emissions(in percent) in Greece in 1993 and the Emissions(in percent) in Guatemala in 1996?
Your response must be concise. -0.05. What is the difference between the Emissions(in percent) of Low income in 1993 and the Emissions(in percent) of Finland in 1997?
Keep it short and to the point. -10.23. What is the difference between the Emissions(in percent) in Low income in 1993 and the Emissions(in percent) in Greece in 1997?
Your answer should be compact. 0.4. What is the difference between the Emissions(in percent) of Low income in 1993 and the Emissions(in percent) of Guatemala in 1997?
Provide a succinct answer. 0.58. What is the difference between the Emissions(in percent) in Finland in 1993 and the Emissions(in percent) in Greece in 1997?
Your answer should be very brief. 10.82. What is the difference between the Emissions(in percent) in Finland in 1993 and the Emissions(in percent) in Guatemala in 1997?
Provide a succinct answer. 10.99. What is the difference between the Emissions(in percent) of Greece in 1993 and the Emissions(in percent) of Guatemala in 1997?
Your answer should be compact. -0.01. What is the difference between the Emissions(in percent) in Low income in 1994 and the Emissions(in percent) in Finland in 1995?
Give a very brief answer. -11.51. What is the difference between the Emissions(in percent) in Low income in 1994 and the Emissions(in percent) in Greece in 1995?
Ensure brevity in your answer.  0.69. What is the difference between the Emissions(in percent) in Low income in 1994 and the Emissions(in percent) in Guatemala in 1995?
Provide a short and direct response. 0.51. What is the difference between the Emissions(in percent) in Finland in 1994 and the Emissions(in percent) in Greece in 1995?
Make the answer very short. 10.86. What is the difference between the Emissions(in percent) of Finland in 1994 and the Emissions(in percent) of Guatemala in 1995?
Your answer should be very brief. 10.68. What is the difference between the Emissions(in percent) of Greece in 1994 and the Emissions(in percent) of Guatemala in 1995?
Offer a very short reply. -0.17. What is the difference between the Emissions(in percent) in Low income in 1994 and the Emissions(in percent) in Finland in 1996?
Provide a short and direct response. -10.27. What is the difference between the Emissions(in percent) of Low income in 1994 and the Emissions(in percent) of Greece in 1996?
Provide a short and direct response. 0.68. What is the difference between the Emissions(in percent) of Low income in 1994 and the Emissions(in percent) of Guatemala in 1996?
Ensure brevity in your answer.  0.49. What is the difference between the Emissions(in percent) in Finland in 1994 and the Emissions(in percent) in Greece in 1996?
Provide a short and direct response. 10.85. What is the difference between the Emissions(in percent) in Finland in 1994 and the Emissions(in percent) in Guatemala in 1996?
Ensure brevity in your answer.  10.66. What is the difference between the Emissions(in percent) of Greece in 1994 and the Emissions(in percent) of Guatemala in 1996?
Ensure brevity in your answer.  -0.19. What is the difference between the Emissions(in percent) of Low income in 1994 and the Emissions(in percent) of Finland in 1997?
Give a very brief answer. -10.29. What is the difference between the Emissions(in percent) in Low income in 1994 and the Emissions(in percent) in Greece in 1997?
Give a very brief answer. 0.35. What is the difference between the Emissions(in percent) in Low income in 1994 and the Emissions(in percent) in Guatemala in 1997?
Ensure brevity in your answer.  0.53. What is the difference between the Emissions(in percent) in Finland in 1994 and the Emissions(in percent) in Greece in 1997?
Provide a short and direct response. 10.52. What is the difference between the Emissions(in percent) of Finland in 1994 and the Emissions(in percent) of Guatemala in 1997?
Your response must be concise. 10.7. What is the difference between the Emissions(in percent) in Greece in 1994 and the Emissions(in percent) in Guatemala in 1997?
Your response must be concise. -0.15. What is the difference between the Emissions(in percent) in Low income in 1995 and the Emissions(in percent) in Finland in 1996?
Your answer should be very brief. -10.32. What is the difference between the Emissions(in percent) of Low income in 1995 and the Emissions(in percent) of Greece in 1996?
Your answer should be compact. 0.63. What is the difference between the Emissions(in percent) in Low income in 1995 and the Emissions(in percent) in Guatemala in 1996?
Provide a succinct answer. 0.44. What is the difference between the Emissions(in percent) in Finland in 1995 and the Emissions(in percent) in Greece in 1996?
Offer a terse response. 12.19. What is the difference between the Emissions(in percent) of Finland in 1995 and the Emissions(in percent) of Guatemala in 1996?
Offer a very short reply. 12. What is the difference between the Emissions(in percent) in Greece in 1995 and the Emissions(in percent) in Guatemala in 1996?
Offer a very short reply. -0.21. What is the difference between the Emissions(in percent) in Low income in 1995 and the Emissions(in percent) in Finland in 1997?
Provide a succinct answer. -10.34. What is the difference between the Emissions(in percent) in Low income in 1995 and the Emissions(in percent) in Greece in 1997?
Provide a succinct answer. 0.3. What is the difference between the Emissions(in percent) in Low income in 1995 and the Emissions(in percent) in Guatemala in 1997?
Give a very brief answer. 0.48. What is the difference between the Emissions(in percent) in Finland in 1995 and the Emissions(in percent) in Greece in 1997?
Keep it short and to the point. 11.87. What is the difference between the Emissions(in percent) in Finland in 1995 and the Emissions(in percent) in Guatemala in 1997?
Ensure brevity in your answer.  12.04. What is the difference between the Emissions(in percent) in Greece in 1995 and the Emissions(in percent) in Guatemala in 1997?
Ensure brevity in your answer.  -0.16. What is the difference between the Emissions(in percent) of Low income in 1996 and the Emissions(in percent) of Finland in 1997?
Offer a terse response. -10.42. What is the difference between the Emissions(in percent) in Low income in 1996 and the Emissions(in percent) in Greece in 1997?
Your answer should be very brief. 0.22. What is the difference between the Emissions(in percent) in Low income in 1996 and the Emissions(in percent) in Guatemala in 1997?
Your answer should be very brief. 0.4. What is the difference between the Emissions(in percent) of Finland in 1996 and the Emissions(in percent) of Greece in 1997?
Provide a short and direct response. 10.62. What is the difference between the Emissions(in percent) in Finland in 1996 and the Emissions(in percent) in Guatemala in 1997?
Give a very brief answer. 10.8. What is the difference between the Emissions(in percent) in Greece in 1996 and the Emissions(in percent) in Guatemala in 1997?
Provide a succinct answer. -0.15. What is the average Emissions(in percent) of Low income per year?
Provide a succinct answer. 0.83. What is the average Emissions(in percent) of Finland per year?
Provide a succinct answer. 10.98. What is the average Emissions(in percent) in Greece per year?
Offer a terse response. 0.3. What is the average Emissions(in percent) of Guatemala per year?
Keep it short and to the point. 0.31. In the year 1990, what is the difference between the Emissions(in percent) of Low income and Emissions(in percent) of Finland?
Make the answer very short. -8.65. In the year 1990, what is the difference between the Emissions(in percent) in Low income and Emissions(in percent) in Greece?
Make the answer very short. 0.58. In the year 1990, what is the difference between the Emissions(in percent) of Low income and Emissions(in percent) of Guatemala?
Provide a succinct answer. 0.65. In the year 1990, what is the difference between the Emissions(in percent) of Finland and Emissions(in percent) of Greece?
Your response must be concise. 9.23. In the year 1990, what is the difference between the Emissions(in percent) in Finland and Emissions(in percent) in Guatemala?
Ensure brevity in your answer.  9.3. In the year 1990, what is the difference between the Emissions(in percent) of Greece and Emissions(in percent) of Guatemala?
Your response must be concise. 0.06. In the year 1991, what is the difference between the Emissions(in percent) in Low income and Emissions(in percent) in Finland?
Your response must be concise. -8.88. In the year 1991, what is the difference between the Emissions(in percent) in Low income and Emissions(in percent) in Greece?
Ensure brevity in your answer.  0.54. In the year 1991, what is the difference between the Emissions(in percent) of Low income and Emissions(in percent) of Guatemala?
Offer a very short reply. 0.67. In the year 1991, what is the difference between the Emissions(in percent) of Finland and Emissions(in percent) of Greece?
Make the answer very short. 9.42. In the year 1991, what is the difference between the Emissions(in percent) of Finland and Emissions(in percent) of Guatemala?
Make the answer very short. 9.55. In the year 1991, what is the difference between the Emissions(in percent) of Greece and Emissions(in percent) of Guatemala?
Offer a very short reply. 0.13. In the year 1992, what is the difference between the Emissions(in percent) of Low income and Emissions(in percent) of Finland?
Give a very brief answer. -10.64. In the year 1992, what is the difference between the Emissions(in percent) in Low income and Emissions(in percent) in Greece?
Provide a succinct answer. 0.51. In the year 1992, what is the difference between the Emissions(in percent) in Low income and Emissions(in percent) in Guatemala?
Give a very brief answer. 0.59. In the year 1992, what is the difference between the Emissions(in percent) of Finland and Emissions(in percent) of Greece?
Provide a short and direct response. 11.16. In the year 1992, what is the difference between the Emissions(in percent) of Finland and Emissions(in percent) of Guatemala?
Ensure brevity in your answer.  11.24. In the year 1992, what is the difference between the Emissions(in percent) of Greece and Emissions(in percent) of Guatemala?
Your answer should be compact. 0.08. In the year 1993, what is the difference between the Emissions(in percent) in Low income and Emissions(in percent) in Finland?
Ensure brevity in your answer.  -10.41. In the year 1993, what is the difference between the Emissions(in percent) of Low income and Emissions(in percent) of Greece?
Offer a very short reply. 0.59. In the year 1993, what is the difference between the Emissions(in percent) of Low income and Emissions(in percent) of Guatemala?
Your answer should be very brief. 0.55. In the year 1993, what is the difference between the Emissions(in percent) in Finland and Emissions(in percent) in Greece?
Ensure brevity in your answer.  11. In the year 1993, what is the difference between the Emissions(in percent) in Finland and Emissions(in percent) in Guatemala?
Your answer should be very brief. 10.96. In the year 1993, what is the difference between the Emissions(in percent) of Greece and Emissions(in percent) of Guatemala?
Ensure brevity in your answer.  -0.04. In the year 1994, what is the difference between the Emissions(in percent) in Low income and Emissions(in percent) in Finland?
Your response must be concise. -10.17. In the year 1994, what is the difference between the Emissions(in percent) of Low income and Emissions(in percent) of Greece?
Ensure brevity in your answer.  0.68. In the year 1994, what is the difference between the Emissions(in percent) of Low income and Emissions(in percent) of Guatemala?
Offer a terse response. 0.55. In the year 1994, what is the difference between the Emissions(in percent) of Finland and Emissions(in percent) of Greece?
Keep it short and to the point. 10.85. In the year 1994, what is the difference between the Emissions(in percent) in Finland and Emissions(in percent) in Guatemala?
Make the answer very short. 10.72. In the year 1994, what is the difference between the Emissions(in percent) of Greece and Emissions(in percent) of Guatemala?
Make the answer very short. -0.13. In the year 1995, what is the difference between the Emissions(in percent) of Low income and Emissions(in percent) of Finland?
Your response must be concise. -11.56. In the year 1995, what is the difference between the Emissions(in percent) of Low income and Emissions(in percent) of Greece?
Give a very brief answer. 0.64. In the year 1995, what is the difference between the Emissions(in percent) in Low income and Emissions(in percent) in Guatemala?
Make the answer very short. 0.46. In the year 1995, what is the difference between the Emissions(in percent) of Finland and Emissions(in percent) of Greece?
Provide a succinct answer. 12.21. In the year 1995, what is the difference between the Emissions(in percent) in Finland and Emissions(in percent) in Guatemala?
Your response must be concise. 12.03. In the year 1995, what is the difference between the Emissions(in percent) of Greece and Emissions(in percent) of Guatemala?
Provide a short and direct response. -0.18. In the year 1996, what is the difference between the Emissions(in percent) of Low income and Emissions(in percent) of Finland?
Offer a very short reply. -10.4. In the year 1996, what is the difference between the Emissions(in percent) in Low income and Emissions(in percent) in Greece?
Provide a succinct answer. 0.55. In the year 1996, what is the difference between the Emissions(in percent) of Low income and Emissions(in percent) of Guatemala?
Offer a very short reply. 0.36. In the year 1996, what is the difference between the Emissions(in percent) in Finland and Emissions(in percent) in Greece?
Provide a short and direct response. 10.95. In the year 1996, what is the difference between the Emissions(in percent) in Finland and Emissions(in percent) in Guatemala?
Your answer should be very brief. 10.76. In the year 1996, what is the difference between the Emissions(in percent) of Greece and Emissions(in percent) of Guatemala?
Offer a very short reply. -0.19. In the year 1997, what is the difference between the Emissions(in percent) in Low income and Emissions(in percent) in Finland?
Give a very brief answer. -10.48. In the year 1997, what is the difference between the Emissions(in percent) in Low income and Emissions(in percent) in Greece?
Your answer should be compact. 0.16. In the year 1997, what is the difference between the Emissions(in percent) of Low income and Emissions(in percent) of Guatemala?
Make the answer very short. 0.34. In the year 1997, what is the difference between the Emissions(in percent) of Finland and Emissions(in percent) of Greece?
Your answer should be very brief. 10.64. In the year 1997, what is the difference between the Emissions(in percent) of Finland and Emissions(in percent) of Guatemala?
Make the answer very short. 10.82. In the year 1997, what is the difference between the Emissions(in percent) in Greece and Emissions(in percent) in Guatemala?
Keep it short and to the point. 0.18. What is the ratio of the Emissions(in percent) of Low income in 1990 to that in 1991?
Ensure brevity in your answer.  1.05. What is the ratio of the Emissions(in percent) in Finland in 1990 to that in 1991?
Offer a terse response. 0.98. What is the ratio of the Emissions(in percent) in Greece in 1990 to that in 1991?
Provide a succinct answer. 1.01. What is the ratio of the Emissions(in percent) in Guatemala in 1990 to that in 1991?
Keep it short and to the point. 1.24. What is the ratio of the Emissions(in percent) in Low income in 1990 to that in 1992?
Your answer should be compact. 1.12. What is the ratio of the Emissions(in percent) of Finland in 1990 to that in 1992?
Provide a short and direct response. 0.84. What is the ratio of the Emissions(in percent) of Greece in 1990 to that in 1992?
Your answer should be very brief. 1.11. What is the ratio of the Emissions(in percent) in Guatemala in 1990 to that in 1992?
Offer a terse response. 1.18. What is the ratio of the Emissions(in percent) of Low income in 1990 to that in 1993?
Your answer should be very brief. 1.15. What is the ratio of the Emissions(in percent) in Finland in 1990 to that in 1993?
Your answer should be very brief. 0.86. What is the ratio of the Emissions(in percent) in Greece in 1990 to that in 1993?
Your answer should be very brief. 1.51. What is the ratio of the Emissions(in percent) in Guatemala in 1990 to that in 1993?
Provide a short and direct response. 1.11. What is the ratio of the Emissions(in percent) in Low income in 1990 to that in 1994?
Offer a terse response. 1.23. What is the ratio of the Emissions(in percent) of Finland in 1990 to that in 1994?
Offer a very short reply. 0.88. What is the ratio of the Emissions(in percent) of Greece in 1990 to that in 1994?
Your response must be concise. 3.01. What is the ratio of the Emissions(in percent) of Guatemala in 1990 to that in 1994?
Offer a terse response. 1.34. What is the ratio of the Emissions(in percent) of Low income in 1990 to that in 1995?
Ensure brevity in your answer.  1.31. What is the ratio of the Emissions(in percent) in Finland in 1990 to that in 1995?
Keep it short and to the point. 0.78. What is the ratio of the Emissions(in percent) of Greece in 1990 to that in 1995?
Offer a very short reply. 3.38. What is the ratio of the Emissions(in percent) in Guatemala in 1990 to that in 1995?
Your answer should be compact. 1.17. What is the ratio of the Emissions(in percent) of Low income in 1990 to that in 1996?
Keep it short and to the point. 1.46. What is the ratio of the Emissions(in percent) of Finland in 1990 to that in 1996?
Offer a very short reply. 0.87. What is the ratio of the Emissions(in percent) in Greece in 1990 to that in 1996?
Keep it short and to the point. 3. What is the ratio of the Emissions(in percent) of Guatemala in 1990 to that in 1996?
Keep it short and to the point. 1.09. What is the ratio of the Emissions(in percent) of Low income in 1990 to that in 1997?
Keep it short and to the point. 1.6. What is the ratio of the Emissions(in percent) of Finland in 1990 to that in 1997?
Keep it short and to the point. 0.87. What is the ratio of the Emissions(in percent) in Greece in 1990 to that in 1997?
Your answer should be compact. 0.91. What is the ratio of the Emissions(in percent) of Guatemala in 1990 to that in 1997?
Your answer should be very brief. 1.24. What is the ratio of the Emissions(in percent) in Low income in 1991 to that in 1992?
Ensure brevity in your answer.  1.07. What is the ratio of the Emissions(in percent) of Finland in 1991 to that in 1992?
Offer a very short reply. 0.85. What is the ratio of the Emissions(in percent) in Greece in 1991 to that in 1992?
Make the answer very short. 1.1. What is the ratio of the Emissions(in percent) of Guatemala in 1991 to that in 1992?
Give a very brief answer. 0.95. What is the ratio of the Emissions(in percent) in Low income in 1991 to that in 1993?
Your answer should be very brief. 1.1. What is the ratio of the Emissions(in percent) of Finland in 1991 to that in 1993?
Offer a very short reply. 0.87. What is the ratio of the Emissions(in percent) of Greece in 1991 to that in 1993?
Provide a short and direct response. 1.5. What is the ratio of the Emissions(in percent) in Guatemala in 1991 to that in 1993?
Your response must be concise. 0.9. What is the ratio of the Emissions(in percent) in Low income in 1991 to that in 1994?
Give a very brief answer. 1.17. What is the ratio of the Emissions(in percent) in Finland in 1991 to that in 1994?
Keep it short and to the point. 0.9. What is the ratio of the Emissions(in percent) of Greece in 1991 to that in 1994?
Provide a succinct answer. 2.98. What is the ratio of the Emissions(in percent) in Guatemala in 1991 to that in 1994?
Your response must be concise. 1.08. What is the ratio of the Emissions(in percent) in Low income in 1991 to that in 1995?
Ensure brevity in your answer.  1.25. What is the ratio of the Emissions(in percent) of Finland in 1991 to that in 1995?
Provide a short and direct response. 0.8. What is the ratio of the Emissions(in percent) in Greece in 1991 to that in 1995?
Ensure brevity in your answer.  3.35. What is the ratio of the Emissions(in percent) of Guatemala in 1991 to that in 1995?
Make the answer very short. 0.95. What is the ratio of the Emissions(in percent) in Low income in 1991 to that in 1996?
Your answer should be compact. 1.39. What is the ratio of the Emissions(in percent) of Finland in 1991 to that in 1996?
Offer a terse response. 0.89. What is the ratio of the Emissions(in percent) in Greece in 1991 to that in 1996?
Offer a very short reply. 2.97. What is the ratio of the Emissions(in percent) of Guatemala in 1991 to that in 1996?
Offer a very short reply. 0.88. What is the ratio of the Emissions(in percent) of Low income in 1991 to that in 1997?
Give a very brief answer. 1.52. What is the ratio of the Emissions(in percent) in Finland in 1991 to that in 1997?
Offer a very short reply. 0.89. What is the ratio of the Emissions(in percent) in Greece in 1991 to that in 1997?
Offer a very short reply. 0.9. What is the ratio of the Emissions(in percent) of Guatemala in 1991 to that in 1997?
Give a very brief answer. 1. What is the ratio of the Emissions(in percent) in Low income in 1992 to that in 1993?
Provide a short and direct response. 1.03. What is the ratio of the Emissions(in percent) of Finland in 1992 to that in 1993?
Make the answer very short. 1.02. What is the ratio of the Emissions(in percent) in Greece in 1992 to that in 1993?
Your answer should be compact. 1.37. What is the ratio of the Emissions(in percent) of Guatemala in 1992 to that in 1993?
Make the answer very short. 0.94. What is the ratio of the Emissions(in percent) in Low income in 1992 to that in 1994?
Provide a short and direct response. 1.1. What is the ratio of the Emissions(in percent) in Finland in 1992 to that in 1994?
Your response must be concise. 1.05. What is the ratio of the Emissions(in percent) of Greece in 1992 to that in 1994?
Offer a very short reply. 2.72. What is the ratio of the Emissions(in percent) of Guatemala in 1992 to that in 1994?
Keep it short and to the point. 1.14. What is the ratio of the Emissions(in percent) of Finland in 1992 to that in 1995?
Make the answer very short. 0.94. What is the ratio of the Emissions(in percent) of Greece in 1992 to that in 1995?
Keep it short and to the point. 3.05. What is the ratio of the Emissions(in percent) in Low income in 1992 to that in 1996?
Provide a short and direct response. 1.3. What is the ratio of the Emissions(in percent) in Finland in 1992 to that in 1996?
Offer a very short reply. 1.04. What is the ratio of the Emissions(in percent) in Greece in 1992 to that in 1996?
Make the answer very short. 2.71. What is the ratio of the Emissions(in percent) in Guatemala in 1992 to that in 1996?
Offer a terse response. 0.92. What is the ratio of the Emissions(in percent) of Low income in 1992 to that in 1997?
Ensure brevity in your answer.  1.43. What is the ratio of the Emissions(in percent) in Finland in 1992 to that in 1997?
Provide a succinct answer. 1.04. What is the ratio of the Emissions(in percent) in Greece in 1992 to that in 1997?
Provide a short and direct response. 0.82. What is the ratio of the Emissions(in percent) in Guatemala in 1992 to that in 1997?
Provide a short and direct response. 1.05. What is the ratio of the Emissions(in percent) of Low income in 1993 to that in 1994?
Your response must be concise. 1.06. What is the ratio of the Emissions(in percent) in Finland in 1993 to that in 1994?
Keep it short and to the point. 1.03. What is the ratio of the Emissions(in percent) in Greece in 1993 to that in 1994?
Ensure brevity in your answer.  1.99. What is the ratio of the Emissions(in percent) in Guatemala in 1993 to that in 1994?
Give a very brief answer. 1.21. What is the ratio of the Emissions(in percent) of Low income in 1993 to that in 1995?
Offer a terse response. 1.13. What is the ratio of the Emissions(in percent) in Finland in 1993 to that in 1995?
Provide a short and direct response. 0.91. What is the ratio of the Emissions(in percent) of Greece in 1993 to that in 1995?
Provide a succinct answer. 2.24. What is the ratio of the Emissions(in percent) in Guatemala in 1993 to that in 1995?
Your answer should be compact. 1.06. What is the ratio of the Emissions(in percent) in Low income in 1993 to that in 1996?
Your answer should be very brief. 1.27. What is the ratio of the Emissions(in percent) of Finland in 1993 to that in 1996?
Give a very brief answer. 1.02. What is the ratio of the Emissions(in percent) in Greece in 1993 to that in 1996?
Your response must be concise. 1.98. What is the ratio of the Emissions(in percent) in Guatemala in 1993 to that in 1996?
Your answer should be compact. 0.98. What is the ratio of the Emissions(in percent) of Low income in 1993 to that in 1997?
Your response must be concise. 1.39. What is the ratio of the Emissions(in percent) of Finland in 1993 to that in 1997?
Offer a very short reply. 1.02. What is the ratio of the Emissions(in percent) in Greece in 1993 to that in 1997?
Offer a terse response. 0.6. What is the ratio of the Emissions(in percent) of Guatemala in 1993 to that in 1997?
Provide a succinct answer. 1.12. What is the ratio of the Emissions(in percent) in Low income in 1994 to that in 1995?
Ensure brevity in your answer.  1.07. What is the ratio of the Emissions(in percent) in Finland in 1994 to that in 1995?
Your response must be concise. 0.89. What is the ratio of the Emissions(in percent) of Greece in 1994 to that in 1995?
Your answer should be compact. 1.12. What is the ratio of the Emissions(in percent) in Guatemala in 1994 to that in 1995?
Keep it short and to the point. 0.87. What is the ratio of the Emissions(in percent) in Low income in 1994 to that in 1996?
Provide a succinct answer. 1.19. What is the ratio of the Emissions(in percent) in Greece in 1994 to that in 1996?
Offer a terse response. 1. What is the ratio of the Emissions(in percent) of Guatemala in 1994 to that in 1996?
Your answer should be very brief. 0.81. What is the ratio of the Emissions(in percent) of Low income in 1994 to that in 1997?
Provide a short and direct response. 1.3. What is the ratio of the Emissions(in percent) in Greece in 1994 to that in 1997?
Give a very brief answer. 0.3. What is the ratio of the Emissions(in percent) of Guatemala in 1994 to that in 1997?
Your answer should be compact. 0.93. What is the ratio of the Emissions(in percent) in Low income in 1995 to that in 1996?
Provide a succinct answer. 1.12. What is the ratio of the Emissions(in percent) of Finland in 1995 to that in 1996?
Your answer should be compact. 1.11. What is the ratio of the Emissions(in percent) in Greece in 1995 to that in 1996?
Your response must be concise. 0.89. What is the ratio of the Emissions(in percent) in Guatemala in 1995 to that in 1996?
Make the answer very short. 0.93. What is the ratio of the Emissions(in percent) in Low income in 1995 to that in 1997?
Provide a short and direct response. 1.22. What is the ratio of the Emissions(in percent) in Finland in 1995 to that in 1997?
Your response must be concise. 1.11. What is the ratio of the Emissions(in percent) of Greece in 1995 to that in 1997?
Give a very brief answer. 0.27. What is the ratio of the Emissions(in percent) in Guatemala in 1995 to that in 1997?
Your answer should be very brief. 1.06. What is the ratio of the Emissions(in percent) in Low income in 1996 to that in 1997?
Make the answer very short. 1.1. What is the ratio of the Emissions(in percent) of Finland in 1996 to that in 1997?
Give a very brief answer. 1. What is the ratio of the Emissions(in percent) in Greece in 1996 to that in 1997?
Give a very brief answer. 0.3. What is the ratio of the Emissions(in percent) in Guatemala in 1996 to that in 1997?
Provide a short and direct response. 1.14. What is the difference between the highest and the second highest Emissions(in percent) in Low income?
Your answer should be very brief. 0.05. What is the difference between the highest and the second highest Emissions(in percent) of Finland?
Provide a succinct answer. 0.79. What is the difference between the highest and the second highest Emissions(in percent) in Greece?
Keep it short and to the point. 0.04. What is the difference between the highest and the second highest Emissions(in percent) of Guatemala?
Your response must be concise. 0.03. What is the difference between the highest and the lowest Emissions(in percent) of Low income?
Make the answer very short. 0.38. What is the difference between the highest and the lowest Emissions(in percent) in Finland?
Offer a very short reply. 2.67. What is the difference between the highest and the lowest Emissions(in percent) of Greece?
Your response must be concise. 0.34. What is the difference between the highest and the lowest Emissions(in percent) in Guatemala?
Provide a short and direct response. 0.09. 